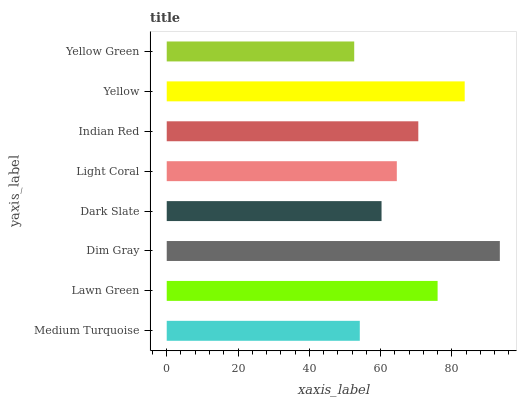Is Yellow Green the minimum?
Answer yes or no. Yes. Is Dim Gray the maximum?
Answer yes or no. Yes. Is Lawn Green the minimum?
Answer yes or no. No. Is Lawn Green the maximum?
Answer yes or no. No. Is Lawn Green greater than Medium Turquoise?
Answer yes or no. Yes. Is Medium Turquoise less than Lawn Green?
Answer yes or no. Yes. Is Medium Turquoise greater than Lawn Green?
Answer yes or no. No. Is Lawn Green less than Medium Turquoise?
Answer yes or no. No. Is Indian Red the high median?
Answer yes or no. Yes. Is Light Coral the low median?
Answer yes or no. Yes. Is Light Coral the high median?
Answer yes or no. No. Is Dark Slate the low median?
Answer yes or no. No. 